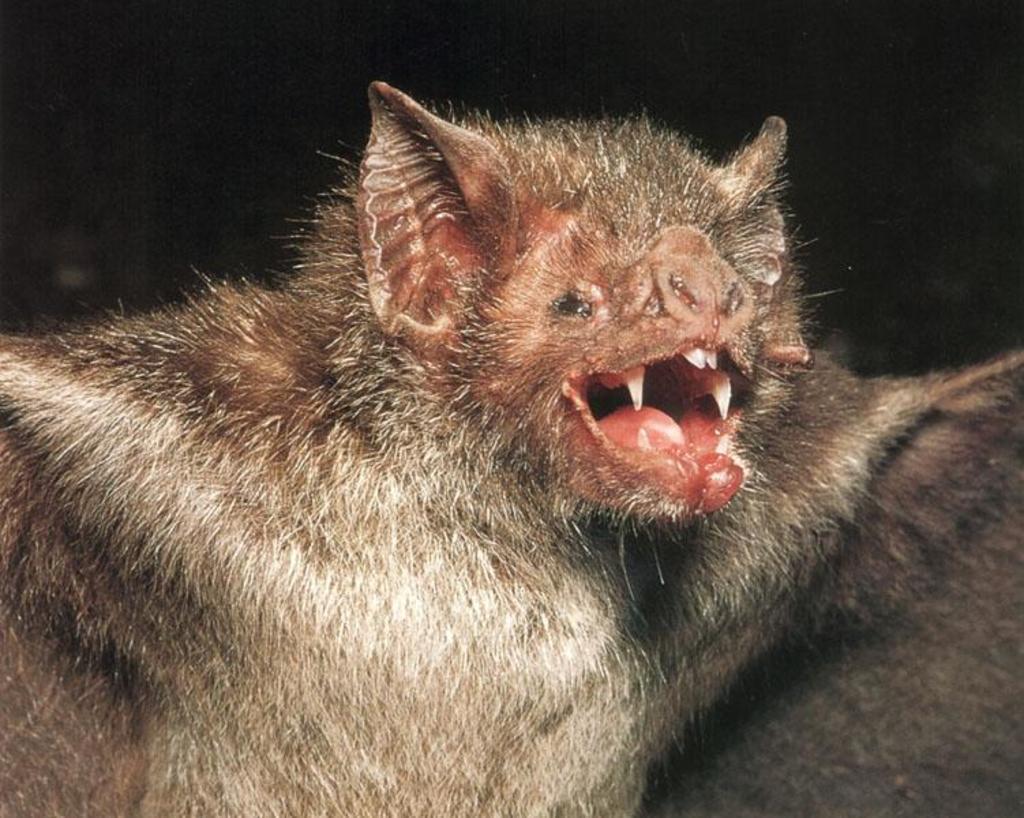Can you describe this image briefly? In this image there is a bat which opened its mouth. 